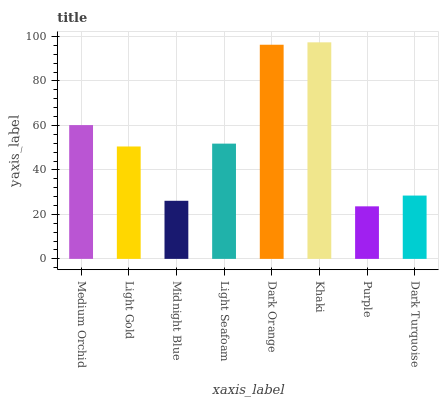Is Purple the minimum?
Answer yes or no. Yes. Is Khaki the maximum?
Answer yes or no. Yes. Is Light Gold the minimum?
Answer yes or no. No. Is Light Gold the maximum?
Answer yes or no. No. Is Medium Orchid greater than Light Gold?
Answer yes or no. Yes. Is Light Gold less than Medium Orchid?
Answer yes or no. Yes. Is Light Gold greater than Medium Orchid?
Answer yes or no. No. Is Medium Orchid less than Light Gold?
Answer yes or no. No. Is Light Seafoam the high median?
Answer yes or no. Yes. Is Light Gold the low median?
Answer yes or no. Yes. Is Light Gold the high median?
Answer yes or no. No. Is Midnight Blue the low median?
Answer yes or no. No. 